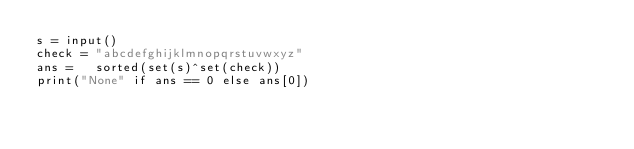Convert code to text. <code><loc_0><loc_0><loc_500><loc_500><_Python_>s = input()
check = "abcdefghijklmnopqrstuvwxyz"
ans =   sorted(set(s)^set(check))
print("None" if ans == 0 else ans[0])
</code> 